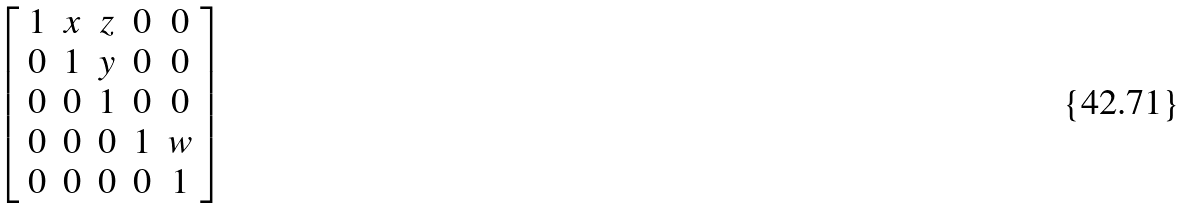Convert formula to latex. <formula><loc_0><loc_0><loc_500><loc_500>\left [ \begin{array} { c c c c c } 1 & x & z & 0 & 0 \\ 0 & 1 & y & 0 & 0 \\ 0 & 0 & 1 & 0 & 0 \\ 0 & 0 & 0 & 1 & w \\ 0 & 0 & 0 & 0 & 1 \end{array} \right ]</formula> 